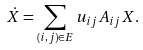<formula> <loc_0><loc_0><loc_500><loc_500>\dot { X } = \sum _ { ( i , j ) \in E } u _ { i j } A _ { i j } X .</formula> 